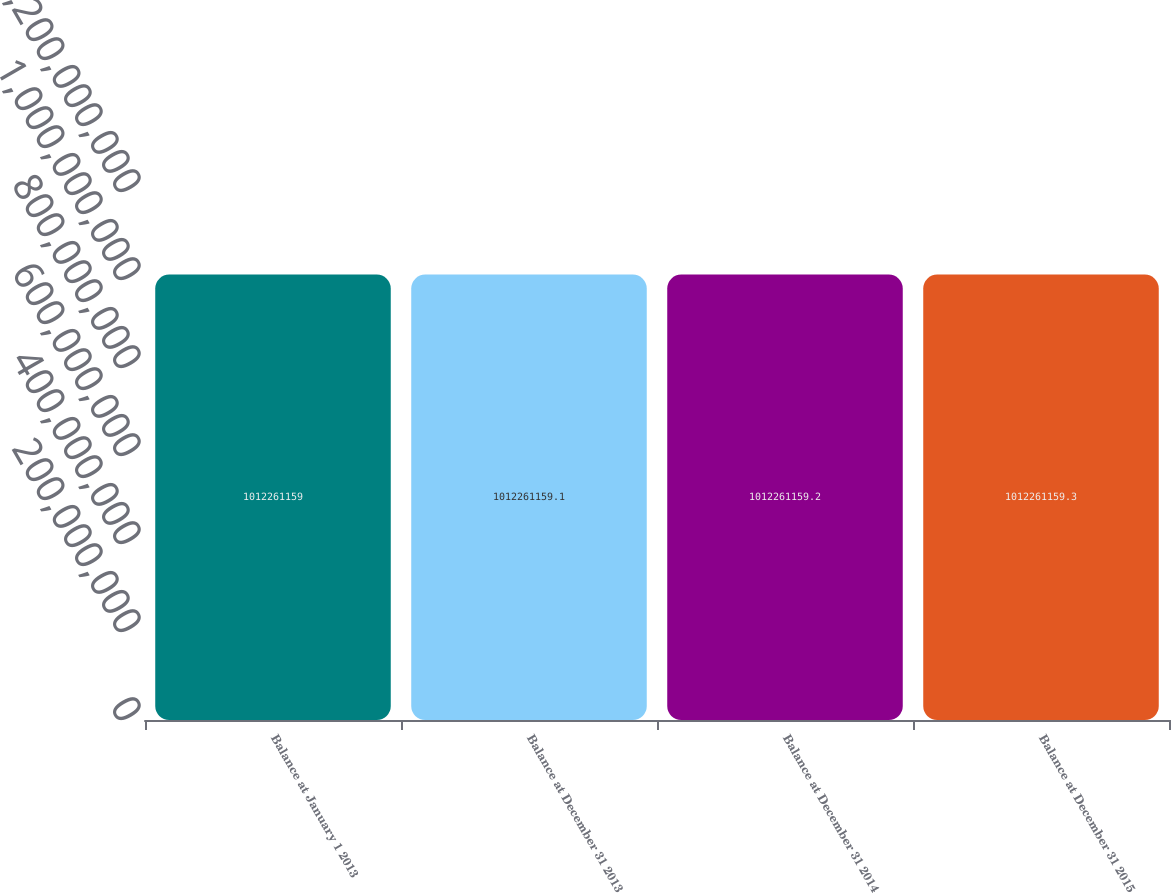Convert chart to OTSL. <chart><loc_0><loc_0><loc_500><loc_500><bar_chart><fcel>Balance at January 1 2013<fcel>Balance at December 31 2013<fcel>Balance at December 31 2014<fcel>Balance at December 31 2015<nl><fcel>1.01226e+09<fcel>1.01226e+09<fcel>1.01226e+09<fcel>1.01226e+09<nl></chart> 